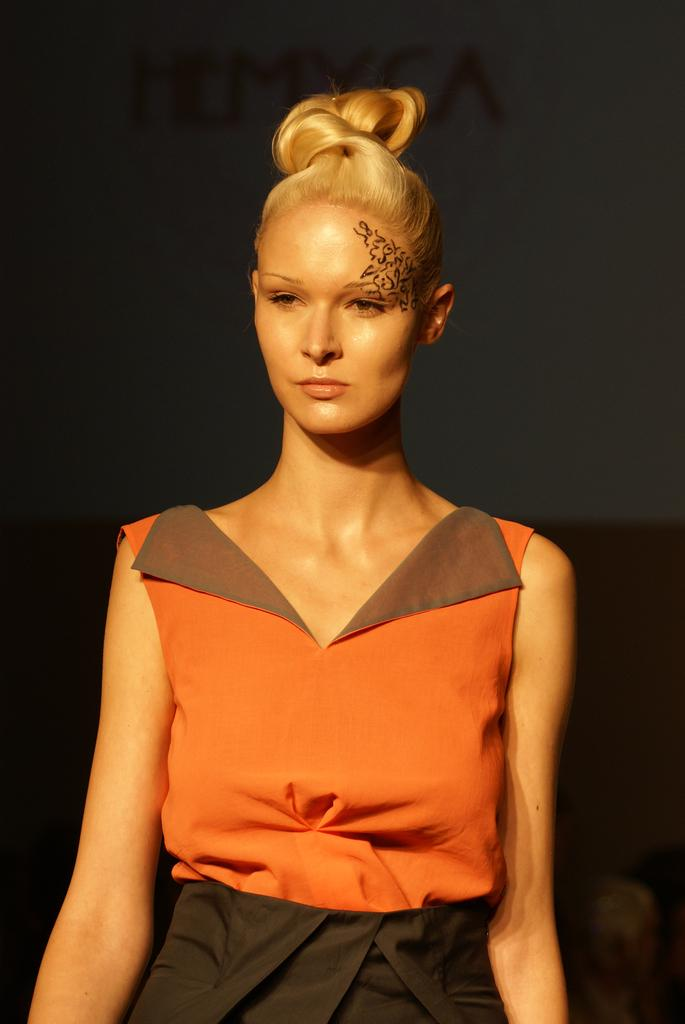What is the main subject of the image? There is a woman in the image. Can you describe any distinguishing features of the woman? The woman has a tattoo on her face. How would you describe the background of the image? The background of the image is blurry. What type of rice is being taught in the image? There is no rice or teaching activity present in the image. What material is the steel used for in the image? There is no steel present in the image. 